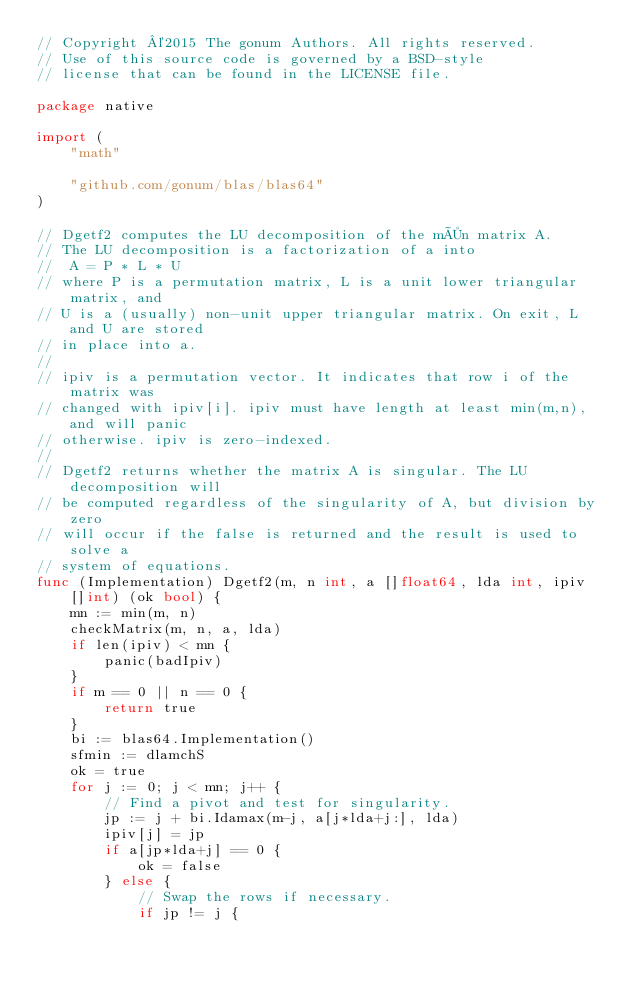Convert code to text. <code><loc_0><loc_0><loc_500><loc_500><_Go_>// Copyright ©2015 The gonum Authors. All rights reserved.
// Use of this source code is governed by a BSD-style
// license that can be found in the LICENSE file.

package native

import (
	"math"

	"github.com/gonum/blas/blas64"
)

// Dgetf2 computes the LU decomposition of the m×n matrix A.
// The LU decomposition is a factorization of a into
//  A = P * L * U
// where P is a permutation matrix, L is a unit lower triangular matrix, and
// U is a (usually) non-unit upper triangular matrix. On exit, L and U are stored
// in place into a.
//
// ipiv is a permutation vector. It indicates that row i of the matrix was
// changed with ipiv[i]. ipiv must have length at least min(m,n), and will panic
// otherwise. ipiv is zero-indexed.
//
// Dgetf2 returns whether the matrix A is singular. The LU decomposition will
// be computed regardless of the singularity of A, but division by zero
// will occur if the false is returned and the result is used to solve a
// system of equations.
func (Implementation) Dgetf2(m, n int, a []float64, lda int, ipiv []int) (ok bool) {
	mn := min(m, n)
	checkMatrix(m, n, a, lda)
	if len(ipiv) < mn {
		panic(badIpiv)
	}
	if m == 0 || n == 0 {
		return true
	}
	bi := blas64.Implementation()
	sfmin := dlamchS
	ok = true
	for j := 0; j < mn; j++ {
		// Find a pivot and test for singularity.
		jp := j + bi.Idamax(m-j, a[j*lda+j:], lda)
		ipiv[j] = jp
		if a[jp*lda+j] == 0 {
			ok = false
		} else {
			// Swap the rows if necessary.
			if jp != j {</code> 